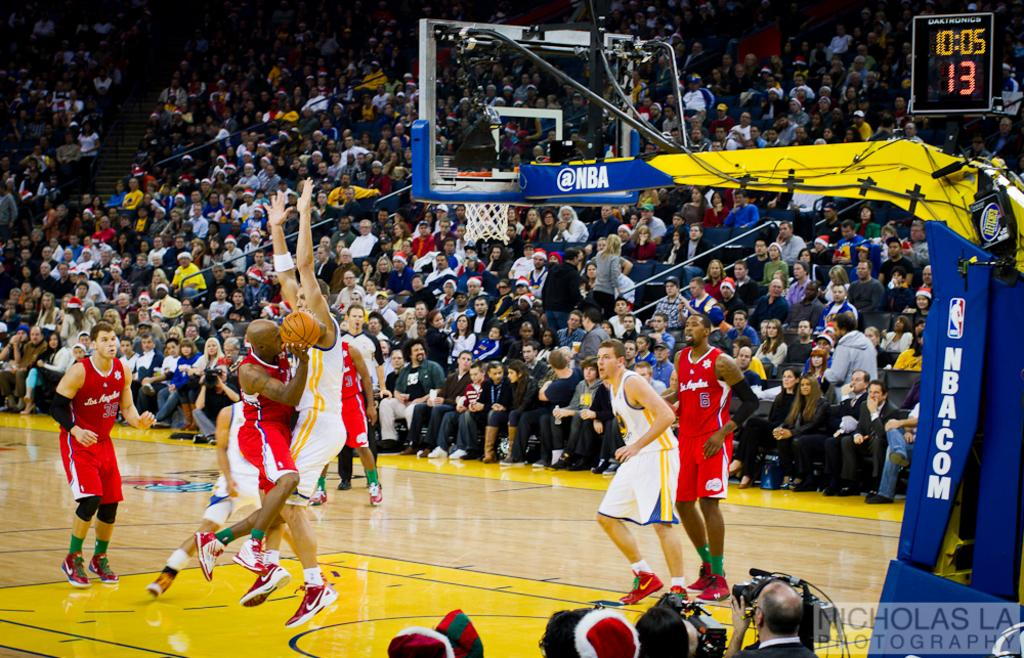<image>
Create a compact narrative representing the image presented. two NBA teams playing basketball with 13 seconds left on the shot clock 